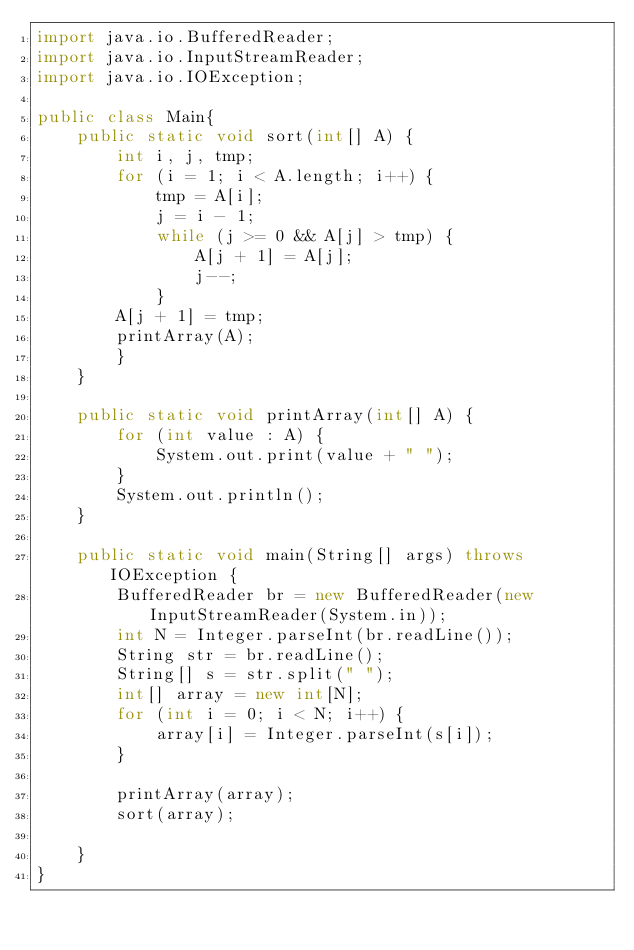<code> <loc_0><loc_0><loc_500><loc_500><_Java_>import java.io.BufferedReader;
import java.io.InputStreamReader;
import java.io.IOException;

public class Main{
    public static void sort(int[] A) {
        int i, j, tmp;
        for (i = 1; i < A.length; i++) {
            tmp = A[i];
            j = i - 1;
            while (j >= 0 && A[j] > tmp) {
                A[j + 1] = A[j];
                j--;
            }
        A[j + 1] = tmp;
        printArray(A);
        }
    }
    
    public static void printArray(int[] A) {
        for (int value : A) {
            System.out.print(value + " ");
        }
        System.out.println();
    }
    
    public static void main(String[] args) throws IOException {
        BufferedReader br = new BufferedReader(new InputStreamReader(System.in));
        int N = Integer.parseInt(br.readLine());
        String str = br.readLine();
        String[] s = str.split(" ");
        int[] array = new int[N];
        for (int i = 0; i < N; i++) {
            array[i] = Integer.parseInt(s[i]);
        }
        
        printArray(array);
        sort(array);
        
    }
}
</code> 